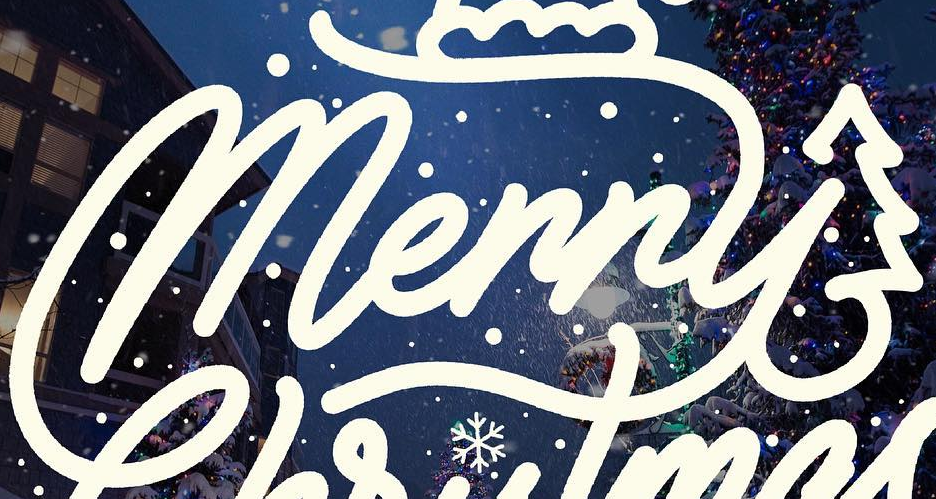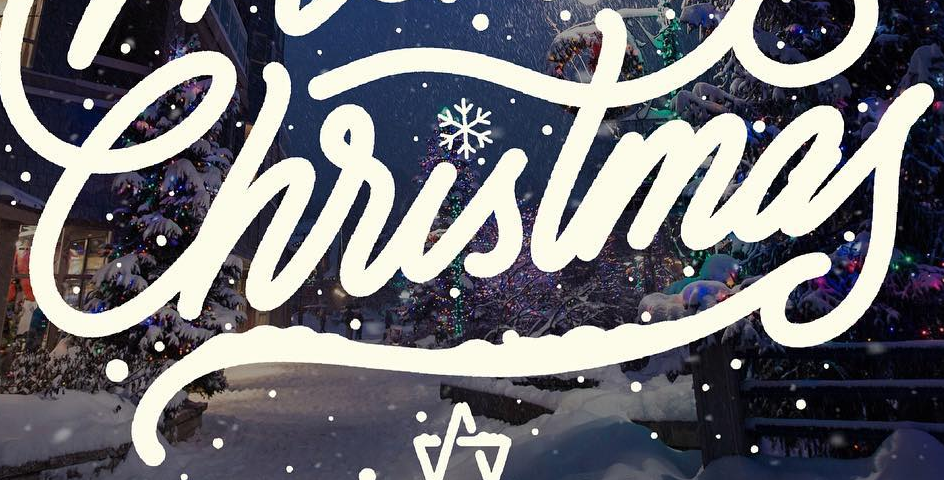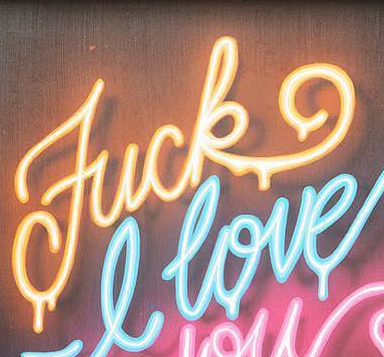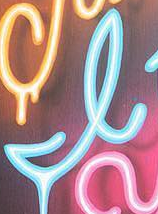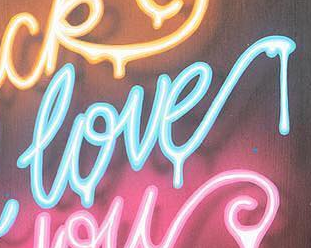Read the text content from these images in order, separated by a semicolon. Merry; Christmas; Fuck; I; love 